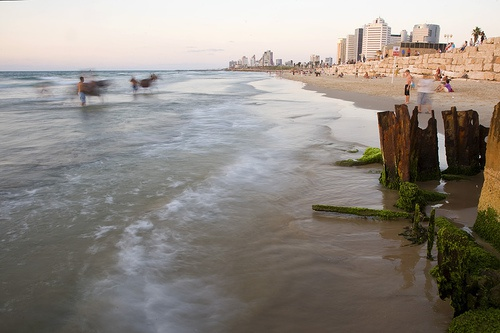Describe the objects in this image and their specific colors. I can see people in gray, tan, and darkgray tones, people in gray, tan, and darkgray tones, horse in gray, black, and darkgray tones, people in gray, darkgray, and brown tones, and horse in gray, black, and darkgray tones in this image. 